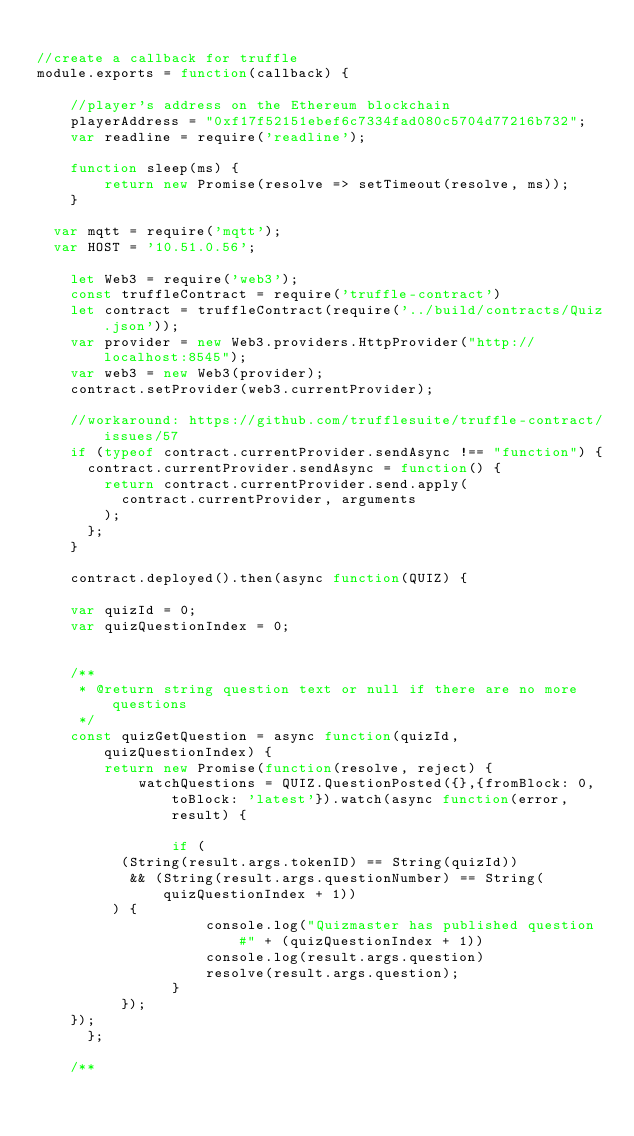<code> <loc_0><loc_0><loc_500><loc_500><_JavaScript_>
//create a callback for truffle
module.exports = function(callback) {

    //player's address on the Ethereum blockchain
    playerAddress = "0xf17f52151ebef6c7334fad080c5704d77216b732";
    var readline = require('readline');

    function sleep(ms) {
        return new Promise(resolve => setTimeout(resolve, ms));
    }

	var mqtt = require('mqtt');
	var HOST = '10.51.0.56';

	  let Web3 = require('web3');
	  const truffleContract = require('truffle-contract')
	  let contract = truffleContract(require('../build/contracts/Quiz.json'));
	  var provider = new Web3.providers.HttpProvider("http://localhost:8545");
	  var web3 = new Web3(provider);
	  contract.setProvider(web3.currentProvider);

	  //workaround: https://github.com/trufflesuite/truffle-contract/issues/57
	  if (typeof contract.currentProvider.sendAsync !== "function") {
	    contract.currentProvider.sendAsync = function() {
	      return contract.currentProvider.send.apply(
	        contract.currentProvider, arguments
	      );
	    };
	  }

	  contract.deployed().then(async function(QUIZ) {

		var quizId = 0;
		var quizQuestionIndex = 0;


		/**
		 * @return string question text or null if there are no more questions
		 */
    const quizGetQuestion = async function(quizId, quizQuestionIndex) {
        return new Promise(function(resolve, reject) {
            watchQuestions = QUIZ.QuestionPosted({},{fromBlock: 0, toBlock: 'latest'}).watch(async function(error, result) {

                if (
					(String(result.args.tokenID) == String(quizId))
					 && (String(result.args.questionNumber) == String(quizQuestionIndex + 1))
				 ) {
                    console.log("Quizmaster has published question #" + (quizQuestionIndex + 1))
                    console.log(result.args.question)
                    resolve(result.args.question);
                }
          });
	  });
      };

		/**</code> 